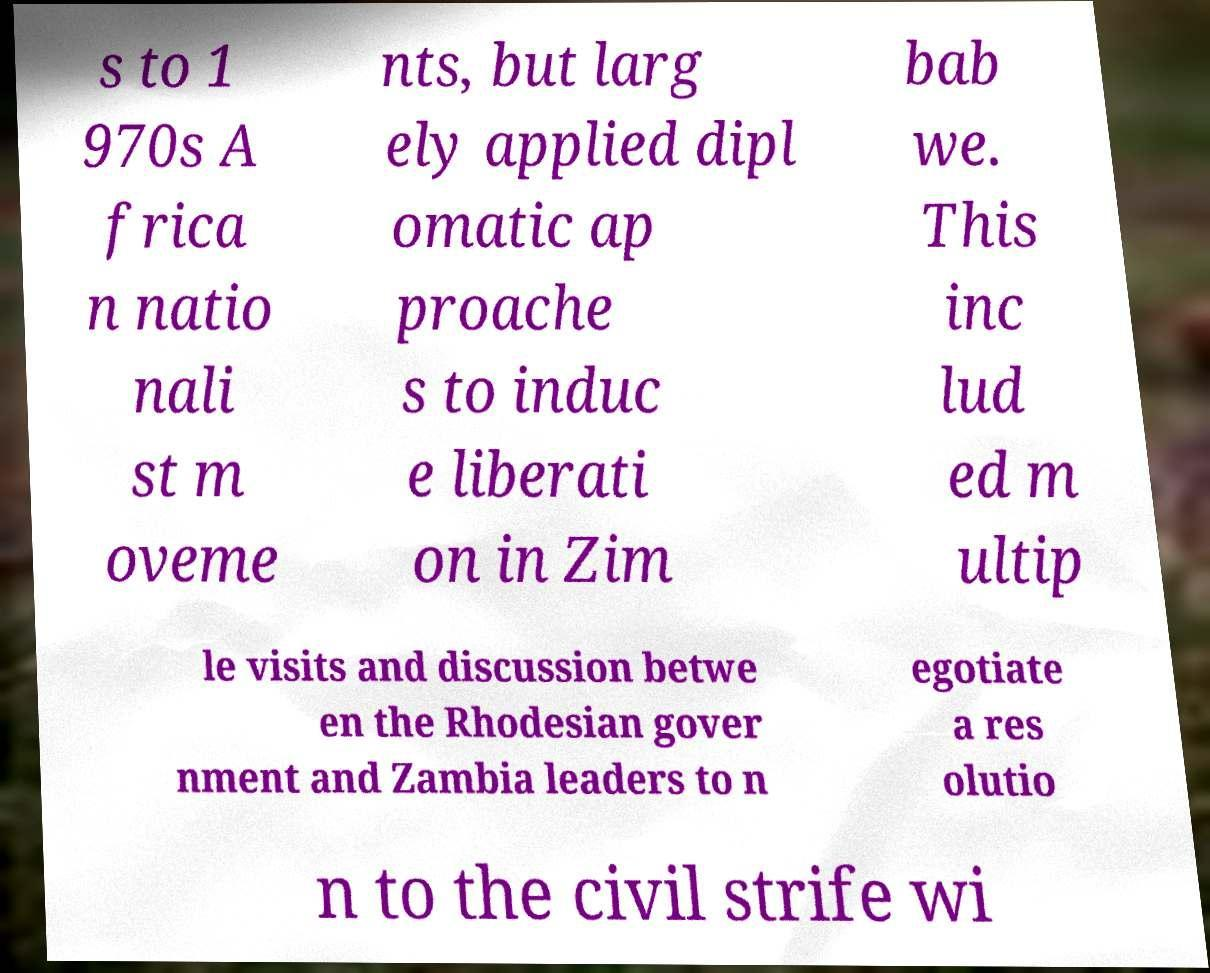What messages or text are displayed in this image? I need them in a readable, typed format. s to 1 970s A frica n natio nali st m oveme nts, but larg ely applied dipl omatic ap proache s to induc e liberati on in Zim bab we. This inc lud ed m ultip le visits and discussion betwe en the Rhodesian gover nment and Zambia leaders to n egotiate a res olutio n to the civil strife wi 